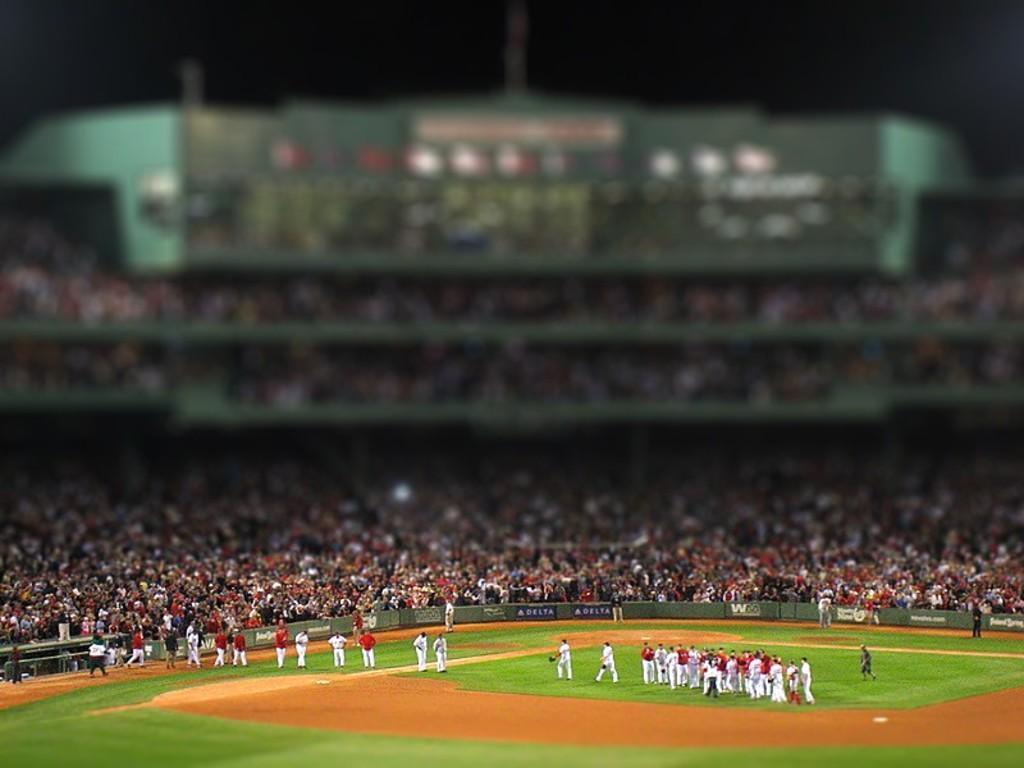Could you give a brief overview of what you see in this image? In this image I can see group of people and they are wearing white and red color dresses and I can also see the stadium. Background I can see few people sitting and the sky is in black color. 